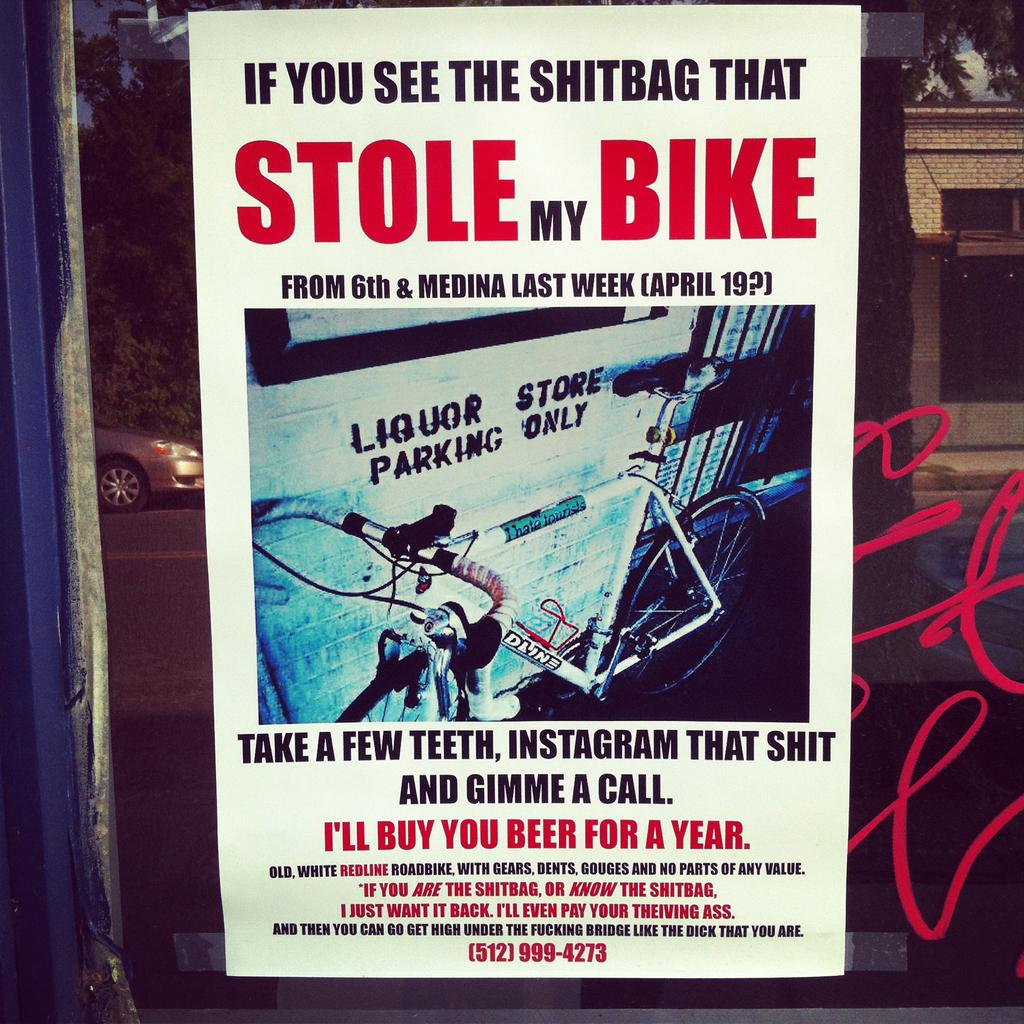<image>
Create a compact narrative representing the image presented. A poster for a stolen bike has beer for a year as a reward. 